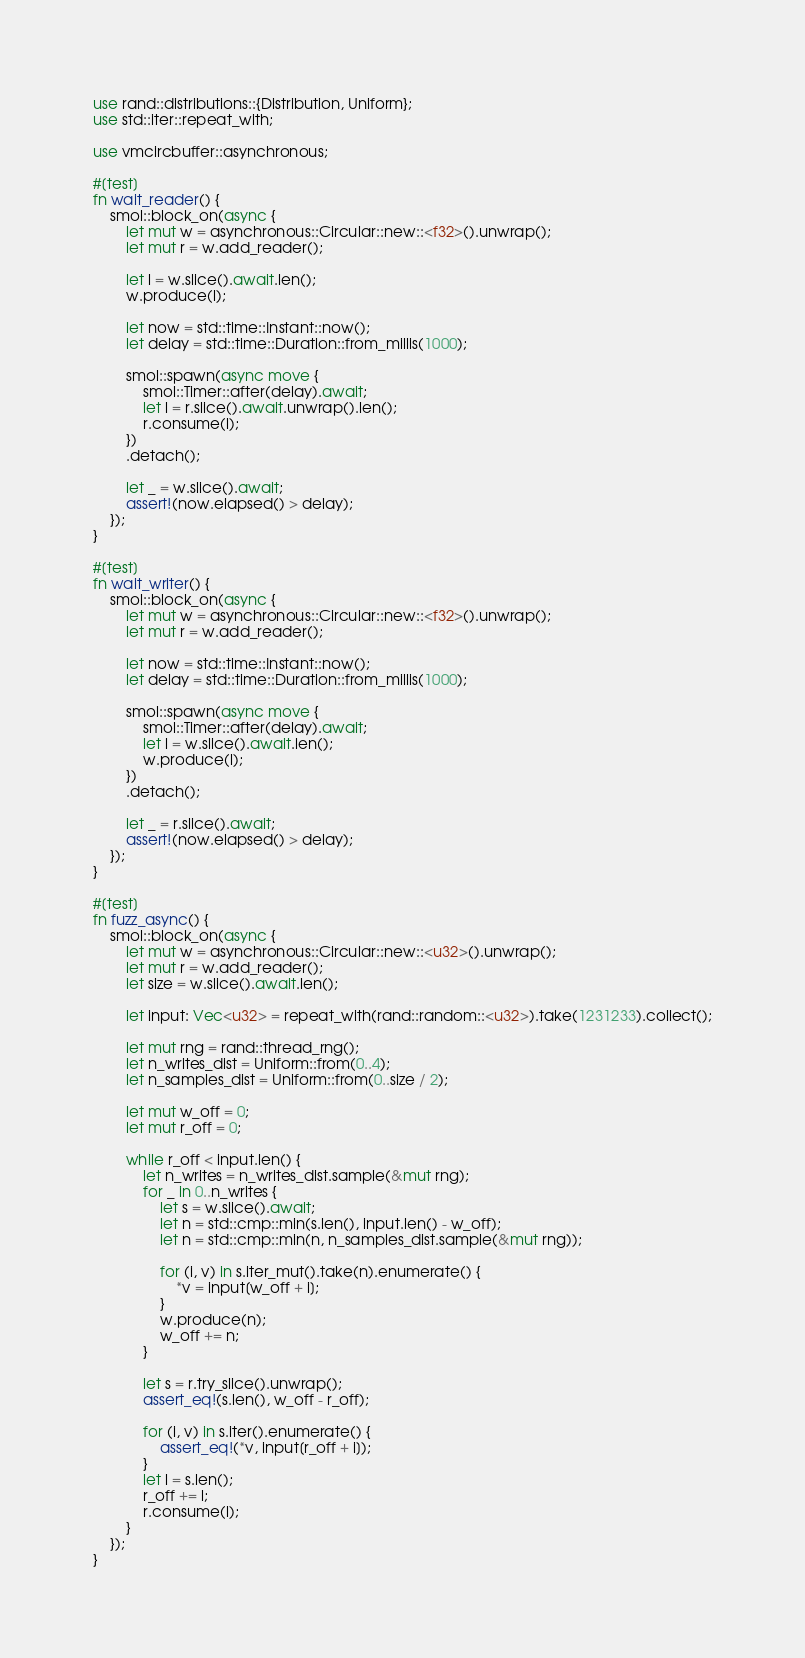Convert code to text. <code><loc_0><loc_0><loc_500><loc_500><_Rust_>use rand::distributions::{Distribution, Uniform};
use std::iter::repeat_with;

use vmcircbuffer::asynchronous;

#[test]
fn wait_reader() {
    smol::block_on(async {
        let mut w = asynchronous::Circular::new::<f32>().unwrap();
        let mut r = w.add_reader();

        let l = w.slice().await.len();
        w.produce(l);

        let now = std::time::Instant::now();
        let delay = std::time::Duration::from_millis(1000);

        smol::spawn(async move {
            smol::Timer::after(delay).await;
            let l = r.slice().await.unwrap().len();
            r.consume(l);
        })
        .detach();

        let _ = w.slice().await;
        assert!(now.elapsed() > delay);
    });
}

#[test]
fn wait_writer() {
    smol::block_on(async {
        let mut w = asynchronous::Circular::new::<f32>().unwrap();
        let mut r = w.add_reader();

        let now = std::time::Instant::now();
        let delay = std::time::Duration::from_millis(1000);

        smol::spawn(async move {
            smol::Timer::after(delay).await;
            let l = w.slice().await.len();
            w.produce(l);
        })
        .detach();

        let _ = r.slice().await;
        assert!(now.elapsed() > delay);
    });
}

#[test]
fn fuzz_async() {
    smol::block_on(async {
        let mut w = asynchronous::Circular::new::<u32>().unwrap();
        let mut r = w.add_reader();
        let size = w.slice().await.len();

        let input: Vec<u32> = repeat_with(rand::random::<u32>).take(1231233).collect();

        let mut rng = rand::thread_rng();
        let n_writes_dist = Uniform::from(0..4);
        let n_samples_dist = Uniform::from(0..size / 2);

        let mut w_off = 0;
        let mut r_off = 0;

        while r_off < input.len() {
            let n_writes = n_writes_dist.sample(&mut rng);
            for _ in 0..n_writes {
                let s = w.slice().await;
                let n = std::cmp::min(s.len(), input.len() - w_off);
                let n = std::cmp::min(n, n_samples_dist.sample(&mut rng));

                for (i, v) in s.iter_mut().take(n).enumerate() {
                    *v = input[w_off + i];
                }
                w.produce(n);
                w_off += n;
            }

            let s = r.try_slice().unwrap();
            assert_eq!(s.len(), w_off - r_off);

            for (i, v) in s.iter().enumerate() {
                assert_eq!(*v, input[r_off + i]);
            }
            let l = s.len();
            r_off += l;
            r.consume(l);
        }
    });
}
</code> 